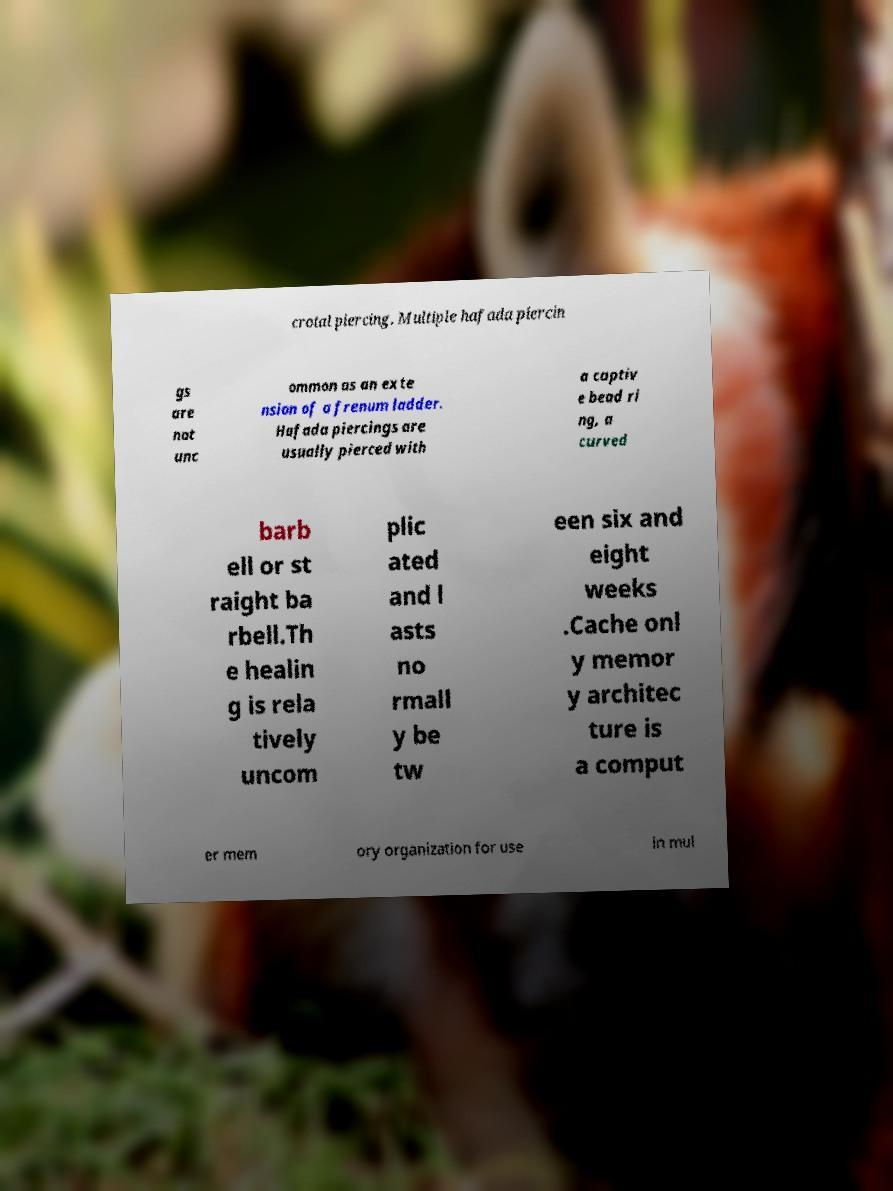I need the written content from this picture converted into text. Can you do that? crotal piercing. Multiple hafada piercin gs are not unc ommon as an exte nsion of a frenum ladder. Hafada piercings are usually pierced with a captiv e bead ri ng, a curved barb ell or st raight ba rbell.Th e healin g is rela tively uncom plic ated and l asts no rmall y be tw een six and eight weeks .Cache onl y memor y architec ture is a comput er mem ory organization for use in mul 